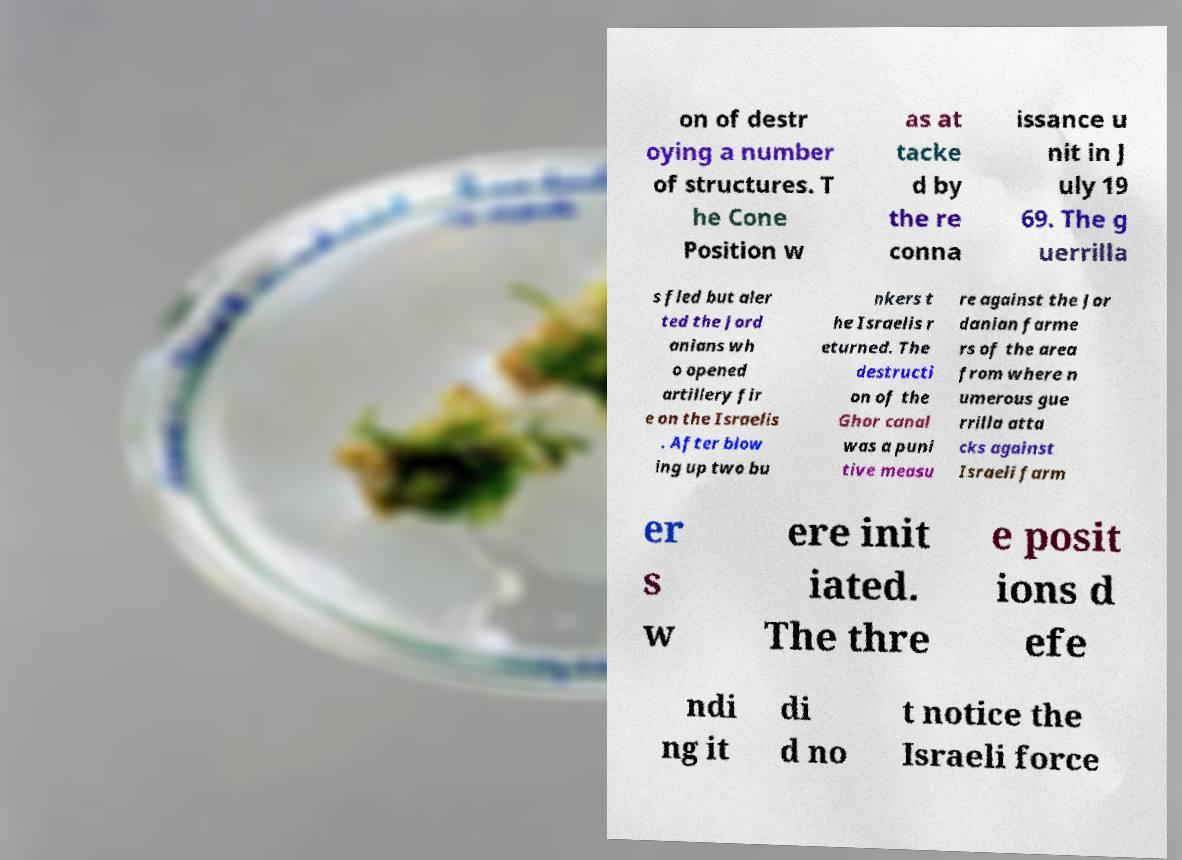There's text embedded in this image that I need extracted. Can you transcribe it verbatim? on of destr oying a number of structures. T he Cone Position w as at tacke d by the re conna issance u nit in J uly 19 69. The g uerrilla s fled but aler ted the Jord anians wh o opened artillery fir e on the Israelis . After blow ing up two bu nkers t he Israelis r eturned. The destructi on of the Ghor canal was a puni tive measu re against the Jor danian farme rs of the area from where n umerous gue rrilla atta cks against Israeli farm er s w ere init iated. The thre e posit ions d efe ndi ng it di d no t notice the Israeli force 